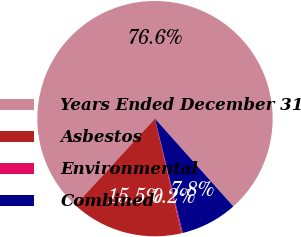Convert chart. <chart><loc_0><loc_0><loc_500><loc_500><pie_chart><fcel>Years Ended December 31<fcel>Asbestos<fcel>Environmental<fcel>Combined<nl><fcel>76.57%<fcel>15.45%<fcel>0.17%<fcel>7.81%<nl></chart> 